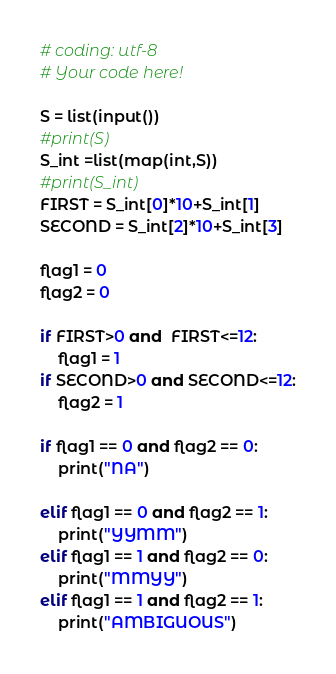<code> <loc_0><loc_0><loc_500><loc_500><_Python_># coding: utf-8
# Your code here!

S = list(input())
#print(S)
S_int =list(map(int,S))
#print(S_int)
FIRST = S_int[0]*10+S_int[1]
SECOND = S_int[2]*10+S_int[3]

flag1 = 0
flag2 = 0

if FIRST>0 and  FIRST<=12:
    flag1 = 1
if SECOND>0 and SECOND<=12:
    flag2 = 1

if flag1 == 0 and flag2 == 0:
    print("NA")
    
elif flag1 == 0 and flag2 == 1:
    print("YYMM")
elif flag1 == 1 and flag2 == 0:
    print("MMYY")
elif flag1 == 1 and flag2 == 1:
    print("AMBIGUOUS")</code> 